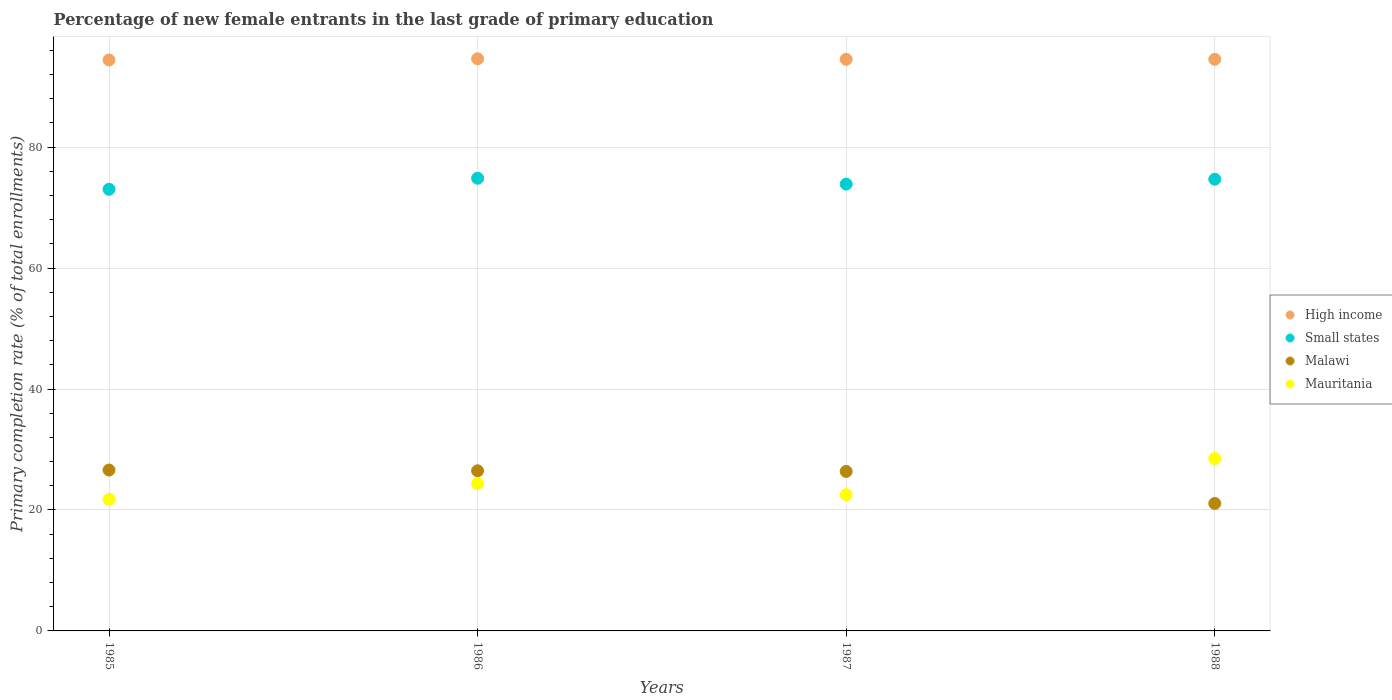Is the number of dotlines equal to the number of legend labels?
Your answer should be compact. Yes. What is the percentage of new female entrants in Mauritania in 1986?
Offer a very short reply. 24.36. Across all years, what is the maximum percentage of new female entrants in Small states?
Your answer should be very brief. 74.85. Across all years, what is the minimum percentage of new female entrants in Small states?
Offer a very short reply. 73.03. In which year was the percentage of new female entrants in Small states maximum?
Provide a short and direct response. 1986. In which year was the percentage of new female entrants in Small states minimum?
Ensure brevity in your answer.  1985. What is the total percentage of new female entrants in Mauritania in the graph?
Make the answer very short. 97.13. What is the difference between the percentage of new female entrants in Small states in 1985 and that in 1986?
Your answer should be compact. -1.82. What is the difference between the percentage of new female entrants in Mauritania in 1985 and the percentage of new female entrants in Malawi in 1986?
Ensure brevity in your answer.  -4.73. What is the average percentage of new female entrants in Mauritania per year?
Provide a short and direct response. 24.28. In the year 1988, what is the difference between the percentage of new female entrants in Small states and percentage of new female entrants in Malawi?
Provide a succinct answer. 53.61. What is the ratio of the percentage of new female entrants in Mauritania in 1986 to that in 1988?
Provide a succinct answer. 0.85. Is the difference between the percentage of new female entrants in Small states in 1985 and 1988 greater than the difference between the percentage of new female entrants in Malawi in 1985 and 1988?
Offer a terse response. No. What is the difference between the highest and the second highest percentage of new female entrants in High income?
Provide a succinct answer. 0.08. What is the difference between the highest and the lowest percentage of new female entrants in Small states?
Provide a succinct answer. 1.82. Is the sum of the percentage of new female entrants in Mauritania in 1986 and 1987 greater than the maximum percentage of new female entrants in High income across all years?
Make the answer very short. No. Is it the case that in every year, the sum of the percentage of new female entrants in High income and percentage of new female entrants in Mauritania  is greater than the sum of percentage of new female entrants in Malawi and percentage of new female entrants in Small states?
Your response must be concise. Yes. Is it the case that in every year, the sum of the percentage of new female entrants in High income and percentage of new female entrants in Small states  is greater than the percentage of new female entrants in Malawi?
Give a very brief answer. Yes. Does the percentage of new female entrants in High income monotonically increase over the years?
Ensure brevity in your answer.  No. Is the percentage of new female entrants in Small states strictly greater than the percentage of new female entrants in Mauritania over the years?
Your response must be concise. Yes. How many dotlines are there?
Make the answer very short. 4. Does the graph contain any zero values?
Provide a succinct answer. No. Does the graph contain grids?
Offer a very short reply. Yes. Where does the legend appear in the graph?
Your answer should be compact. Center right. What is the title of the graph?
Your answer should be very brief. Percentage of new female entrants in the last grade of primary education. What is the label or title of the X-axis?
Provide a short and direct response. Years. What is the label or title of the Y-axis?
Your answer should be compact. Primary completion rate (% of total enrollments). What is the Primary completion rate (% of total enrollments) in High income in 1985?
Your answer should be very brief. 94.4. What is the Primary completion rate (% of total enrollments) of Small states in 1985?
Ensure brevity in your answer.  73.03. What is the Primary completion rate (% of total enrollments) of Malawi in 1985?
Offer a terse response. 26.6. What is the Primary completion rate (% of total enrollments) in Mauritania in 1985?
Offer a very short reply. 21.74. What is the Primary completion rate (% of total enrollments) in High income in 1986?
Offer a very short reply. 94.6. What is the Primary completion rate (% of total enrollments) in Small states in 1986?
Provide a succinct answer. 74.85. What is the Primary completion rate (% of total enrollments) in Malawi in 1986?
Provide a succinct answer. 26.48. What is the Primary completion rate (% of total enrollments) of Mauritania in 1986?
Your answer should be very brief. 24.36. What is the Primary completion rate (% of total enrollments) in High income in 1987?
Offer a very short reply. 94.51. What is the Primary completion rate (% of total enrollments) in Small states in 1987?
Your answer should be very brief. 73.88. What is the Primary completion rate (% of total enrollments) of Malawi in 1987?
Offer a very short reply. 26.37. What is the Primary completion rate (% of total enrollments) of Mauritania in 1987?
Make the answer very short. 22.52. What is the Primary completion rate (% of total enrollments) of High income in 1988?
Your answer should be compact. 94.51. What is the Primary completion rate (% of total enrollments) in Small states in 1988?
Offer a very short reply. 74.69. What is the Primary completion rate (% of total enrollments) of Malawi in 1988?
Provide a succinct answer. 21.08. What is the Primary completion rate (% of total enrollments) in Mauritania in 1988?
Your answer should be compact. 28.5. Across all years, what is the maximum Primary completion rate (% of total enrollments) in High income?
Offer a terse response. 94.6. Across all years, what is the maximum Primary completion rate (% of total enrollments) of Small states?
Make the answer very short. 74.85. Across all years, what is the maximum Primary completion rate (% of total enrollments) in Malawi?
Your answer should be compact. 26.6. Across all years, what is the maximum Primary completion rate (% of total enrollments) in Mauritania?
Provide a short and direct response. 28.5. Across all years, what is the minimum Primary completion rate (% of total enrollments) in High income?
Your answer should be compact. 94.4. Across all years, what is the minimum Primary completion rate (% of total enrollments) in Small states?
Give a very brief answer. 73.03. Across all years, what is the minimum Primary completion rate (% of total enrollments) of Malawi?
Provide a short and direct response. 21.08. Across all years, what is the minimum Primary completion rate (% of total enrollments) of Mauritania?
Your answer should be compact. 21.74. What is the total Primary completion rate (% of total enrollments) of High income in the graph?
Provide a short and direct response. 378.02. What is the total Primary completion rate (% of total enrollments) of Small states in the graph?
Offer a terse response. 296.44. What is the total Primary completion rate (% of total enrollments) of Malawi in the graph?
Offer a very short reply. 100.53. What is the total Primary completion rate (% of total enrollments) of Mauritania in the graph?
Provide a succinct answer. 97.13. What is the difference between the Primary completion rate (% of total enrollments) of High income in 1985 and that in 1986?
Make the answer very short. -0.19. What is the difference between the Primary completion rate (% of total enrollments) of Small states in 1985 and that in 1986?
Your answer should be very brief. -1.82. What is the difference between the Primary completion rate (% of total enrollments) in Malawi in 1985 and that in 1986?
Your response must be concise. 0.12. What is the difference between the Primary completion rate (% of total enrollments) of Mauritania in 1985 and that in 1986?
Keep it short and to the point. -2.61. What is the difference between the Primary completion rate (% of total enrollments) in High income in 1985 and that in 1987?
Your answer should be very brief. -0.11. What is the difference between the Primary completion rate (% of total enrollments) of Small states in 1985 and that in 1987?
Your response must be concise. -0.85. What is the difference between the Primary completion rate (% of total enrollments) of Malawi in 1985 and that in 1987?
Keep it short and to the point. 0.23. What is the difference between the Primary completion rate (% of total enrollments) of Mauritania in 1985 and that in 1987?
Ensure brevity in your answer.  -0.78. What is the difference between the Primary completion rate (% of total enrollments) of High income in 1985 and that in 1988?
Offer a terse response. -0.11. What is the difference between the Primary completion rate (% of total enrollments) in Small states in 1985 and that in 1988?
Your answer should be compact. -1.66. What is the difference between the Primary completion rate (% of total enrollments) in Malawi in 1985 and that in 1988?
Provide a short and direct response. 5.52. What is the difference between the Primary completion rate (% of total enrollments) of Mauritania in 1985 and that in 1988?
Provide a short and direct response. -6.76. What is the difference between the Primary completion rate (% of total enrollments) in High income in 1986 and that in 1987?
Ensure brevity in your answer.  0.09. What is the difference between the Primary completion rate (% of total enrollments) in Small states in 1986 and that in 1987?
Provide a short and direct response. 0.97. What is the difference between the Primary completion rate (% of total enrollments) of Malawi in 1986 and that in 1987?
Provide a short and direct response. 0.11. What is the difference between the Primary completion rate (% of total enrollments) in Mauritania in 1986 and that in 1987?
Offer a very short reply. 1.84. What is the difference between the Primary completion rate (% of total enrollments) of High income in 1986 and that in 1988?
Provide a succinct answer. 0.08. What is the difference between the Primary completion rate (% of total enrollments) in Small states in 1986 and that in 1988?
Give a very brief answer. 0.16. What is the difference between the Primary completion rate (% of total enrollments) of Malawi in 1986 and that in 1988?
Make the answer very short. 5.4. What is the difference between the Primary completion rate (% of total enrollments) of Mauritania in 1986 and that in 1988?
Your answer should be very brief. -4.14. What is the difference between the Primary completion rate (% of total enrollments) of High income in 1987 and that in 1988?
Provide a short and direct response. -0. What is the difference between the Primary completion rate (% of total enrollments) of Small states in 1987 and that in 1988?
Give a very brief answer. -0.81. What is the difference between the Primary completion rate (% of total enrollments) in Malawi in 1987 and that in 1988?
Ensure brevity in your answer.  5.3. What is the difference between the Primary completion rate (% of total enrollments) in Mauritania in 1987 and that in 1988?
Ensure brevity in your answer.  -5.98. What is the difference between the Primary completion rate (% of total enrollments) in High income in 1985 and the Primary completion rate (% of total enrollments) in Small states in 1986?
Offer a terse response. 19.56. What is the difference between the Primary completion rate (% of total enrollments) in High income in 1985 and the Primary completion rate (% of total enrollments) in Malawi in 1986?
Make the answer very short. 67.93. What is the difference between the Primary completion rate (% of total enrollments) in High income in 1985 and the Primary completion rate (% of total enrollments) in Mauritania in 1986?
Your answer should be very brief. 70.04. What is the difference between the Primary completion rate (% of total enrollments) in Small states in 1985 and the Primary completion rate (% of total enrollments) in Malawi in 1986?
Your response must be concise. 46.55. What is the difference between the Primary completion rate (% of total enrollments) in Small states in 1985 and the Primary completion rate (% of total enrollments) in Mauritania in 1986?
Offer a very short reply. 48.67. What is the difference between the Primary completion rate (% of total enrollments) in Malawi in 1985 and the Primary completion rate (% of total enrollments) in Mauritania in 1986?
Your answer should be compact. 2.24. What is the difference between the Primary completion rate (% of total enrollments) in High income in 1985 and the Primary completion rate (% of total enrollments) in Small states in 1987?
Make the answer very short. 20.52. What is the difference between the Primary completion rate (% of total enrollments) in High income in 1985 and the Primary completion rate (% of total enrollments) in Malawi in 1987?
Your response must be concise. 68.03. What is the difference between the Primary completion rate (% of total enrollments) of High income in 1985 and the Primary completion rate (% of total enrollments) of Mauritania in 1987?
Provide a succinct answer. 71.88. What is the difference between the Primary completion rate (% of total enrollments) in Small states in 1985 and the Primary completion rate (% of total enrollments) in Malawi in 1987?
Offer a terse response. 46.65. What is the difference between the Primary completion rate (% of total enrollments) of Small states in 1985 and the Primary completion rate (% of total enrollments) of Mauritania in 1987?
Provide a short and direct response. 50.5. What is the difference between the Primary completion rate (% of total enrollments) of Malawi in 1985 and the Primary completion rate (% of total enrollments) of Mauritania in 1987?
Offer a terse response. 4.08. What is the difference between the Primary completion rate (% of total enrollments) of High income in 1985 and the Primary completion rate (% of total enrollments) of Small states in 1988?
Provide a succinct answer. 19.72. What is the difference between the Primary completion rate (% of total enrollments) of High income in 1985 and the Primary completion rate (% of total enrollments) of Malawi in 1988?
Provide a succinct answer. 73.33. What is the difference between the Primary completion rate (% of total enrollments) in High income in 1985 and the Primary completion rate (% of total enrollments) in Mauritania in 1988?
Provide a short and direct response. 65.9. What is the difference between the Primary completion rate (% of total enrollments) of Small states in 1985 and the Primary completion rate (% of total enrollments) of Malawi in 1988?
Make the answer very short. 51.95. What is the difference between the Primary completion rate (% of total enrollments) in Small states in 1985 and the Primary completion rate (% of total enrollments) in Mauritania in 1988?
Your answer should be compact. 44.52. What is the difference between the Primary completion rate (% of total enrollments) in Malawi in 1985 and the Primary completion rate (% of total enrollments) in Mauritania in 1988?
Offer a terse response. -1.9. What is the difference between the Primary completion rate (% of total enrollments) of High income in 1986 and the Primary completion rate (% of total enrollments) of Small states in 1987?
Your answer should be compact. 20.72. What is the difference between the Primary completion rate (% of total enrollments) of High income in 1986 and the Primary completion rate (% of total enrollments) of Malawi in 1987?
Your response must be concise. 68.22. What is the difference between the Primary completion rate (% of total enrollments) in High income in 1986 and the Primary completion rate (% of total enrollments) in Mauritania in 1987?
Provide a succinct answer. 72.07. What is the difference between the Primary completion rate (% of total enrollments) in Small states in 1986 and the Primary completion rate (% of total enrollments) in Malawi in 1987?
Keep it short and to the point. 48.48. What is the difference between the Primary completion rate (% of total enrollments) of Small states in 1986 and the Primary completion rate (% of total enrollments) of Mauritania in 1987?
Your answer should be compact. 52.32. What is the difference between the Primary completion rate (% of total enrollments) of Malawi in 1986 and the Primary completion rate (% of total enrollments) of Mauritania in 1987?
Provide a succinct answer. 3.95. What is the difference between the Primary completion rate (% of total enrollments) in High income in 1986 and the Primary completion rate (% of total enrollments) in Small states in 1988?
Your answer should be very brief. 19.91. What is the difference between the Primary completion rate (% of total enrollments) of High income in 1986 and the Primary completion rate (% of total enrollments) of Malawi in 1988?
Make the answer very short. 73.52. What is the difference between the Primary completion rate (% of total enrollments) of High income in 1986 and the Primary completion rate (% of total enrollments) of Mauritania in 1988?
Provide a short and direct response. 66.09. What is the difference between the Primary completion rate (% of total enrollments) of Small states in 1986 and the Primary completion rate (% of total enrollments) of Malawi in 1988?
Make the answer very short. 53.77. What is the difference between the Primary completion rate (% of total enrollments) of Small states in 1986 and the Primary completion rate (% of total enrollments) of Mauritania in 1988?
Offer a terse response. 46.35. What is the difference between the Primary completion rate (% of total enrollments) of Malawi in 1986 and the Primary completion rate (% of total enrollments) of Mauritania in 1988?
Your answer should be compact. -2.03. What is the difference between the Primary completion rate (% of total enrollments) in High income in 1987 and the Primary completion rate (% of total enrollments) in Small states in 1988?
Offer a very short reply. 19.82. What is the difference between the Primary completion rate (% of total enrollments) of High income in 1987 and the Primary completion rate (% of total enrollments) of Malawi in 1988?
Keep it short and to the point. 73.43. What is the difference between the Primary completion rate (% of total enrollments) of High income in 1987 and the Primary completion rate (% of total enrollments) of Mauritania in 1988?
Provide a succinct answer. 66.01. What is the difference between the Primary completion rate (% of total enrollments) of Small states in 1987 and the Primary completion rate (% of total enrollments) of Malawi in 1988?
Keep it short and to the point. 52.8. What is the difference between the Primary completion rate (% of total enrollments) in Small states in 1987 and the Primary completion rate (% of total enrollments) in Mauritania in 1988?
Your response must be concise. 45.38. What is the difference between the Primary completion rate (% of total enrollments) of Malawi in 1987 and the Primary completion rate (% of total enrollments) of Mauritania in 1988?
Offer a very short reply. -2.13. What is the average Primary completion rate (% of total enrollments) of High income per year?
Provide a succinct answer. 94.51. What is the average Primary completion rate (% of total enrollments) in Small states per year?
Give a very brief answer. 74.11. What is the average Primary completion rate (% of total enrollments) of Malawi per year?
Provide a succinct answer. 25.13. What is the average Primary completion rate (% of total enrollments) of Mauritania per year?
Provide a short and direct response. 24.28. In the year 1985, what is the difference between the Primary completion rate (% of total enrollments) in High income and Primary completion rate (% of total enrollments) in Small states?
Offer a terse response. 21.38. In the year 1985, what is the difference between the Primary completion rate (% of total enrollments) in High income and Primary completion rate (% of total enrollments) in Malawi?
Give a very brief answer. 67.8. In the year 1985, what is the difference between the Primary completion rate (% of total enrollments) in High income and Primary completion rate (% of total enrollments) in Mauritania?
Your response must be concise. 72.66. In the year 1985, what is the difference between the Primary completion rate (% of total enrollments) in Small states and Primary completion rate (% of total enrollments) in Malawi?
Keep it short and to the point. 46.43. In the year 1985, what is the difference between the Primary completion rate (% of total enrollments) of Small states and Primary completion rate (% of total enrollments) of Mauritania?
Your response must be concise. 51.28. In the year 1985, what is the difference between the Primary completion rate (% of total enrollments) in Malawi and Primary completion rate (% of total enrollments) in Mauritania?
Offer a terse response. 4.86. In the year 1986, what is the difference between the Primary completion rate (% of total enrollments) in High income and Primary completion rate (% of total enrollments) in Small states?
Make the answer very short. 19.75. In the year 1986, what is the difference between the Primary completion rate (% of total enrollments) of High income and Primary completion rate (% of total enrollments) of Malawi?
Offer a very short reply. 68.12. In the year 1986, what is the difference between the Primary completion rate (% of total enrollments) in High income and Primary completion rate (% of total enrollments) in Mauritania?
Offer a terse response. 70.24. In the year 1986, what is the difference between the Primary completion rate (% of total enrollments) in Small states and Primary completion rate (% of total enrollments) in Malawi?
Your answer should be compact. 48.37. In the year 1986, what is the difference between the Primary completion rate (% of total enrollments) of Small states and Primary completion rate (% of total enrollments) of Mauritania?
Your answer should be very brief. 50.49. In the year 1986, what is the difference between the Primary completion rate (% of total enrollments) in Malawi and Primary completion rate (% of total enrollments) in Mauritania?
Ensure brevity in your answer.  2.12. In the year 1987, what is the difference between the Primary completion rate (% of total enrollments) of High income and Primary completion rate (% of total enrollments) of Small states?
Your response must be concise. 20.63. In the year 1987, what is the difference between the Primary completion rate (% of total enrollments) of High income and Primary completion rate (% of total enrollments) of Malawi?
Provide a short and direct response. 68.14. In the year 1987, what is the difference between the Primary completion rate (% of total enrollments) of High income and Primary completion rate (% of total enrollments) of Mauritania?
Provide a short and direct response. 71.99. In the year 1987, what is the difference between the Primary completion rate (% of total enrollments) in Small states and Primary completion rate (% of total enrollments) in Malawi?
Make the answer very short. 47.51. In the year 1987, what is the difference between the Primary completion rate (% of total enrollments) of Small states and Primary completion rate (% of total enrollments) of Mauritania?
Offer a very short reply. 51.36. In the year 1987, what is the difference between the Primary completion rate (% of total enrollments) of Malawi and Primary completion rate (% of total enrollments) of Mauritania?
Your response must be concise. 3.85. In the year 1988, what is the difference between the Primary completion rate (% of total enrollments) in High income and Primary completion rate (% of total enrollments) in Small states?
Your answer should be very brief. 19.83. In the year 1988, what is the difference between the Primary completion rate (% of total enrollments) of High income and Primary completion rate (% of total enrollments) of Malawi?
Your response must be concise. 73.44. In the year 1988, what is the difference between the Primary completion rate (% of total enrollments) of High income and Primary completion rate (% of total enrollments) of Mauritania?
Your answer should be very brief. 66.01. In the year 1988, what is the difference between the Primary completion rate (% of total enrollments) of Small states and Primary completion rate (% of total enrollments) of Malawi?
Give a very brief answer. 53.61. In the year 1988, what is the difference between the Primary completion rate (% of total enrollments) of Small states and Primary completion rate (% of total enrollments) of Mauritania?
Your answer should be compact. 46.19. In the year 1988, what is the difference between the Primary completion rate (% of total enrollments) of Malawi and Primary completion rate (% of total enrollments) of Mauritania?
Offer a terse response. -7.43. What is the ratio of the Primary completion rate (% of total enrollments) of Small states in 1985 to that in 1986?
Offer a very short reply. 0.98. What is the ratio of the Primary completion rate (% of total enrollments) in Malawi in 1985 to that in 1986?
Ensure brevity in your answer.  1. What is the ratio of the Primary completion rate (% of total enrollments) of Mauritania in 1985 to that in 1986?
Your response must be concise. 0.89. What is the ratio of the Primary completion rate (% of total enrollments) of High income in 1985 to that in 1987?
Your answer should be very brief. 1. What is the ratio of the Primary completion rate (% of total enrollments) in Small states in 1985 to that in 1987?
Your response must be concise. 0.99. What is the ratio of the Primary completion rate (% of total enrollments) of Malawi in 1985 to that in 1987?
Offer a terse response. 1.01. What is the ratio of the Primary completion rate (% of total enrollments) of Mauritania in 1985 to that in 1987?
Give a very brief answer. 0.97. What is the ratio of the Primary completion rate (% of total enrollments) in High income in 1985 to that in 1988?
Keep it short and to the point. 1. What is the ratio of the Primary completion rate (% of total enrollments) of Small states in 1985 to that in 1988?
Give a very brief answer. 0.98. What is the ratio of the Primary completion rate (% of total enrollments) of Malawi in 1985 to that in 1988?
Offer a very short reply. 1.26. What is the ratio of the Primary completion rate (% of total enrollments) in Mauritania in 1985 to that in 1988?
Offer a very short reply. 0.76. What is the ratio of the Primary completion rate (% of total enrollments) in High income in 1986 to that in 1987?
Offer a very short reply. 1. What is the ratio of the Primary completion rate (% of total enrollments) in Small states in 1986 to that in 1987?
Provide a succinct answer. 1.01. What is the ratio of the Primary completion rate (% of total enrollments) of Malawi in 1986 to that in 1987?
Give a very brief answer. 1. What is the ratio of the Primary completion rate (% of total enrollments) in Mauritania in 1986 to that in 1987?
Provide a succinct answer. 1.08. What is the ratio of the Primary completion rate (% of total enrollments) in Small states in 1986 to that in 1988?
Provide a succinct answer. 1. What is the ratio of the Primary completion rate (% of total enrollments) of Malawi in 1986 to that in 1988?
Make the answer very short. 1.26. What is the ratio of the Primary completion rate (% of total enrollments) in Mauritania in 1986 to that in 1988?
Offer a very short reply. 0.85. What is the ratio of the Primary completion rate (% of total enrollments) of Malawi in 1987 to that in 1988?
Provide a succinct answer. 1.25. What is the ratio of the Primary completion rate (% of total enrollments) of Mauritania in 1987 to that in 1988?
Your answer should be compact. 0.79. What is the difference between the highest and the second highest Primary completion rate (% of total enrollments) of High income?
Your answer should be very brief. 0.08. What is the difference between the highest and the second highest Primary completion rate (% of total enrollments) in Small states?
Offer a very short reply. 0.16. What is the difference between the highest and the second highest Primary completion rate (% of total enrollments) in Malawi?
Provide a succinct answer. 0.12. What is the difference between the highest and the second highest Primary completion rate (% of total enrollments) in Mauritania?
Keep it short and to the point. 4.14. What is the difference between the highest and the lowest Primary completion rate (% of total enrollments) of High income?
Your answer should be compact. 0.19. What is the difference between the highest and the lowest Primary completion rate (% of total enrollments) of Small states?
Your answer should be very brief. 1.82. What is the difference between the highest and the lowest Primary completion rate (% of total enrollments) of Malawi?
Your response must be concise. 5.52. What is the difference between the highest and the lowest Primary completion rate (% of total enrollments) of Mauritania?
Your response must be concise. 6.76. 